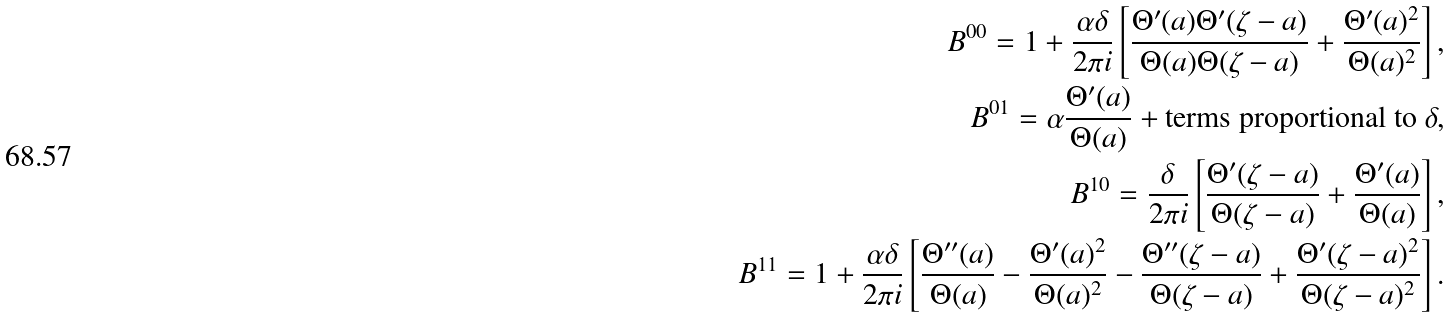Convert formula to latex. <formula><loc_0><loc_0><loc_500><loc_500>B ^ { 0 0 } = 1 + \frac { \alpha \delta } { 2 \pi i } \left [ \frac { \Theta ^ { \prime } ( a ) \Theta ^ { \prime } ( \zeta - a ) } { \Theta ( a ) \Theta ( \zeta - a ) } + \frac { \Theta ^ { \prime } ( a ) ^ { 2 } } { \Theta ( a ) ^ { 2 } } \right ] , \\ B ^ { 0 1 } = \alpha \frac { \Theta ^ { \prime } ( a ) } { \Theta ( a ) } + \text {terms proportional to } \delta , \\ B ^ { 1 0 } = \frac { \delta } { 2 \pi i } \left [ \frac { \Theta ^ { \prime } ( \zeta - a ) } { \Theta ( \zeta - a ) } + \frac { \Theta ^ { \prime } ( a ) } { \Theta ( a ) } \right ] , \\ B ^ { 1 1 } = 1 + \frac { \alpha \delta } { 2 \pi i } \left [ \frac { \Theta ^ { \prime \prime } ( a ) } { \Theta ( a ) } - \frac { \Theta ^ { \prime } ( a ) ^ { 2 } } { \Theta ( a ) ^ { 2 } } - \frac { \Theta ^ { \prime \prime } ( \zeta - a ) } { \Theta ( \zeta - a ) } + \frac { \Theta ^ { \prime } ( \zeta - a ) ^ { 2 } } { \Theta ( \zeta - a ) ^ { 2 } } \right ] .</formula> 